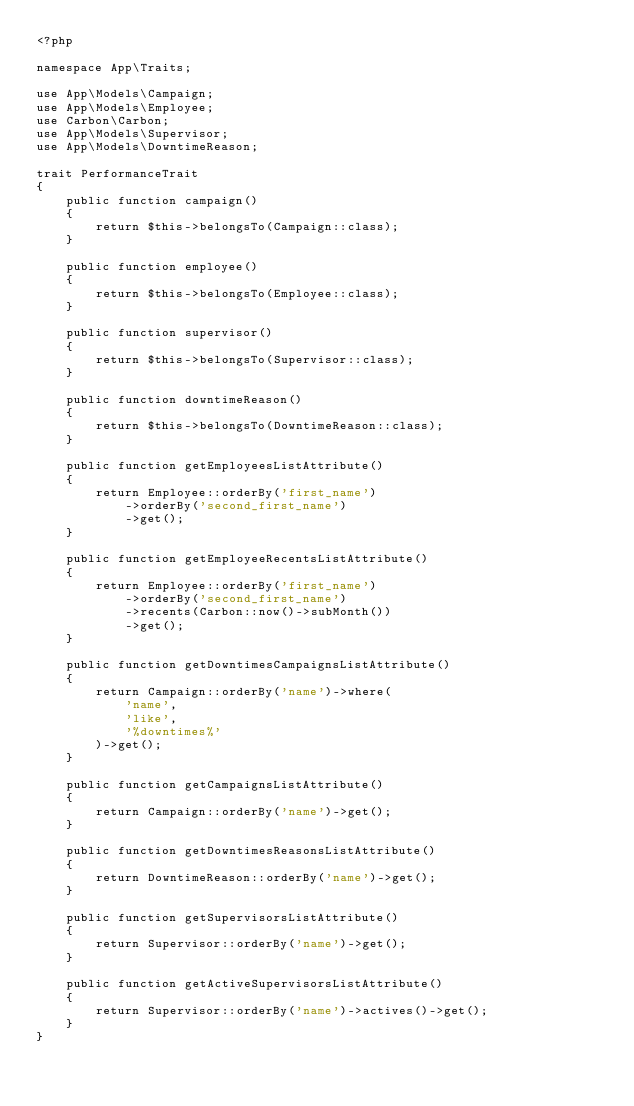<code> <loc_0><loc_0><loc_500><loc_500><_PHP_><?php

namespace App\Traits;

use App\Models\Campaign;
use App\Models\Employee;
use Carbon\Carbon;
use App\Models\Supervisor;
use App\Models\DowntimeReason;

trait PerformanceTrait
{
    public function campaign()
    {
        return $this->belongsTo(Campaign::class);
    }

    public function employee()
    {
        return $this->belongsTo(Employee::class);
    }

    public function supervisor()
    {
        return $this->belongsTo(Supervisor::class);
    }

    public function downtimeReason()
    {
        return $this->belongsTo(DowntimeReason::class);
    }

    public function getEmployeesListAttribute()
    {
        return Employee::orderBy('first_name')
            ->orderBy('second_first_name')
            ->get();
    }

    public function getEmployeeRecentsListAttribute()
    {
        return Employee::orderBy('first_name')
            ->orderBy('second_first_name')
            ->recents(Carbon::now()->subMonth())
            ->get();
    }

    public function getDowntimesCampaignsListAttribute()
    {
        return Campaign::orderBy('name')->where(
            'name',
            'like',
            '%downtimes%'
        )->get();
    }

    public function getCampaignsListAttribute()
    {
        return Campaign::orderBy('name')->get();
    }

    public function getDowntimesReasonsListAttribute()
    {
        return DowntimeReason::orderBy('name')->get();
    }

    public function getSupervisorsListAttribute()
    {
        return Supervisor::orderBy('name')->get();
    }

    public function getActiveSupervisorsListAttribute()
    {
        return Supervisor::orderBy('name')->actives()->get();
    }
}
</code> 